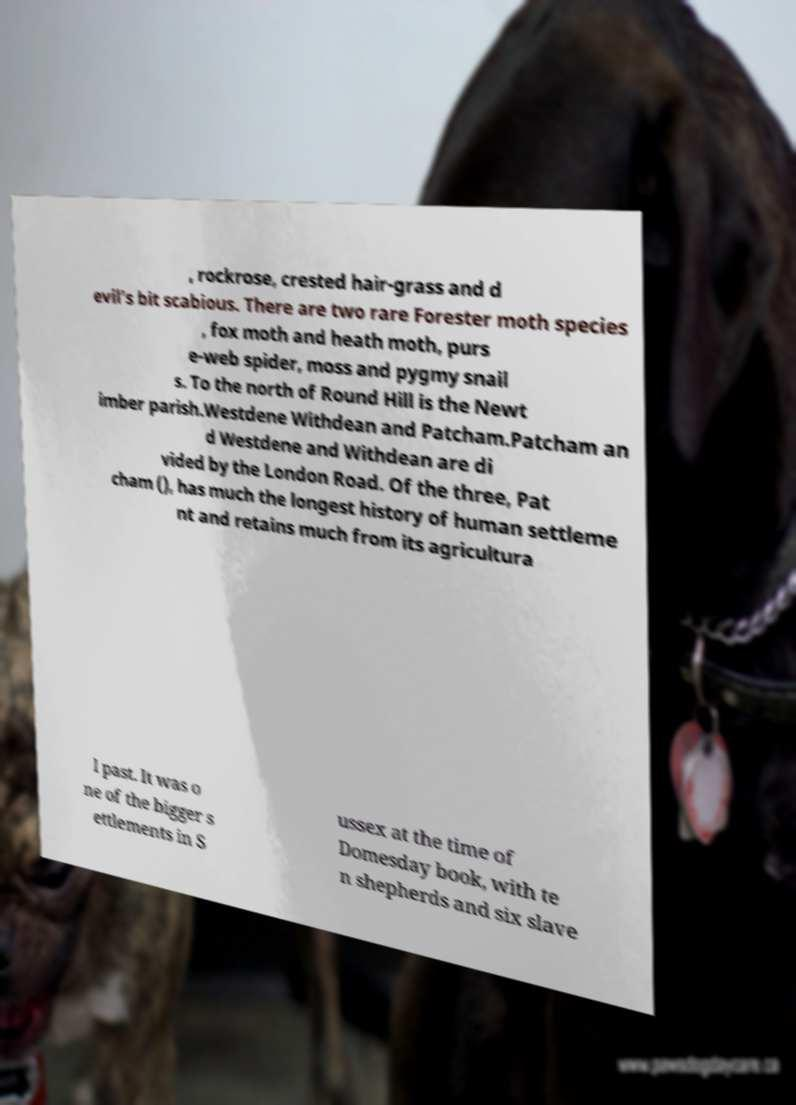Can you accurately transcribe the text from the provided image for me? , rockrose, crested hair-grass and d evil’s bit scabious. There are two rare Forester moth species , fox moth and heath moth, purs e-web spider, moss and pygmy snail s. To the north of Round Hill is the Newt imber parish.Westdene Withdean and Patcham.Patcham an d Westdene and Withdean are di vided by the London Road. Of the three, Pat cham (), has much the longest history of human settleme nt and retains much from its agricultura l past. It was o ne of the bigger s ettlements in S ussex at the time of Domesday book, with te n shepherds and six slave 